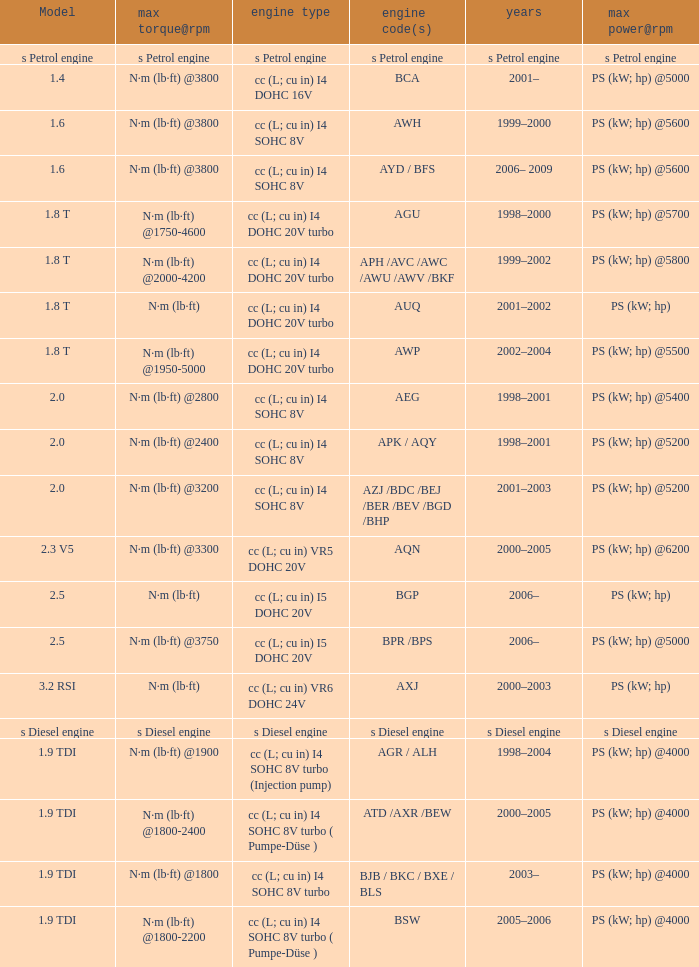Which engine type was used in the model 2.3 v5? Cc (l; cu in) vr5 dohc 20v. 